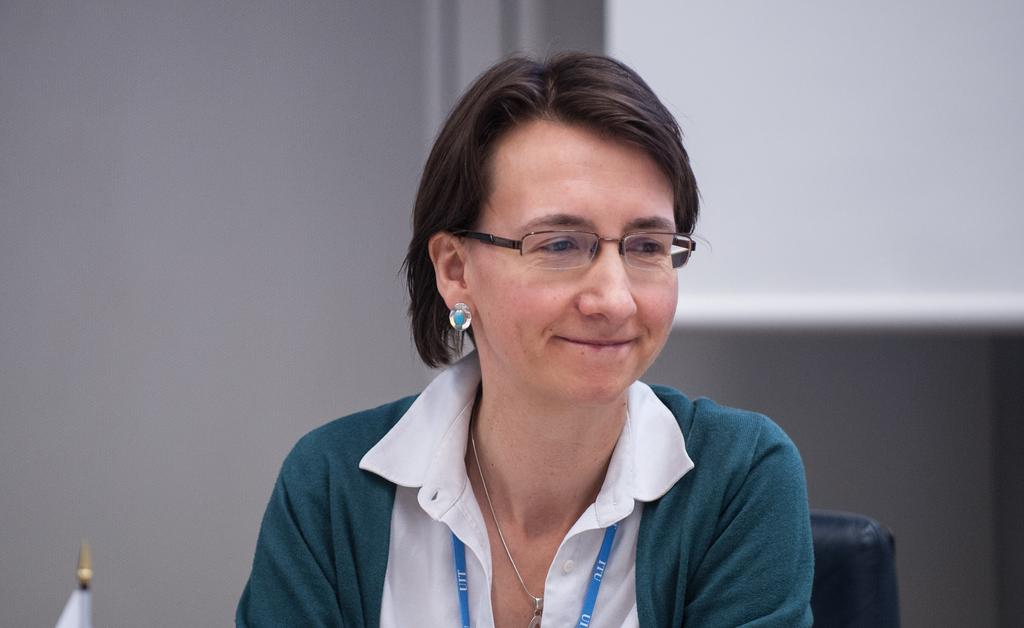Who is in the image? There is a woman in the image. What is the woman wearing on her upper body? The woman is wearing a green jacket and a white shirt. What is the woman doing in the image? The woman is sitting in a chair. What can be seen in the background of the image? There is a wall and a projector screen in the background of the image. What type of birds can be seen flying around the projector screen in the image? There are no birds present in the image; it only features a woman sitting in a chair, a wall, and a projector screen in the background. 